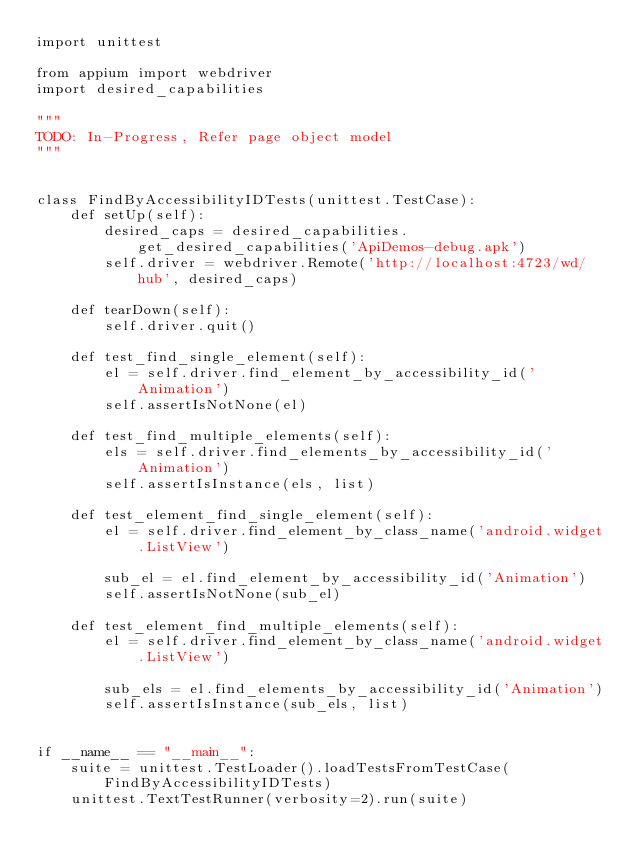<code> <loc_0><loc_0><loc_500><loc_500><_Python_>import unittest

from appium import webdriver
import desired_capabilities

"""
TODO: In-Progress, Refer page object model
"""


class FindByAccessibilityIDTests(unittest.TestCase):
    def setUp(self):
        desired_caps = desired_capabilities.get_desired_capabilities('ApiDemos-debug.apk')
        self.driver = webdriver.Remote('http://localhost:4723/wd/hub', desired_caps)

    def tearDown(self):
        self.driver.quit()

    def test_find_single_element(self):
        el = self.driver.find_element_by_accessibility_id('Animation')
        self.assertIsNotNone(el)

    def test_find_multiple_elements(self):
        els = self.driver.find_elements_by_accessibility_id('Animation')
        self.assertIsInstance(els, list)

    def test_element_find_single_element(self):
        el = self.driver.find_element_by_class_name('android.widget.ListView')

        sub_el = el.find_element_by_accessibility_id('Animation')
        self.assertIsNotNone(sub_el)

    def test_element_find_multiple_elements(self):
        el = self.driver.find_element_by_class_name('android.widget.ListView')

        sub_els = el.find_elements_by_accessibility_id('Animation')
        self.assertIsInstance(sub_els, list)


if __name__ == "__main__":
    suite = unittest.TestLoader().loadTestsFromTestCase(FindByAccessibilityIDTests)
    unittest.TextTestRunner(verbosity=2).run(suite)
</code> 